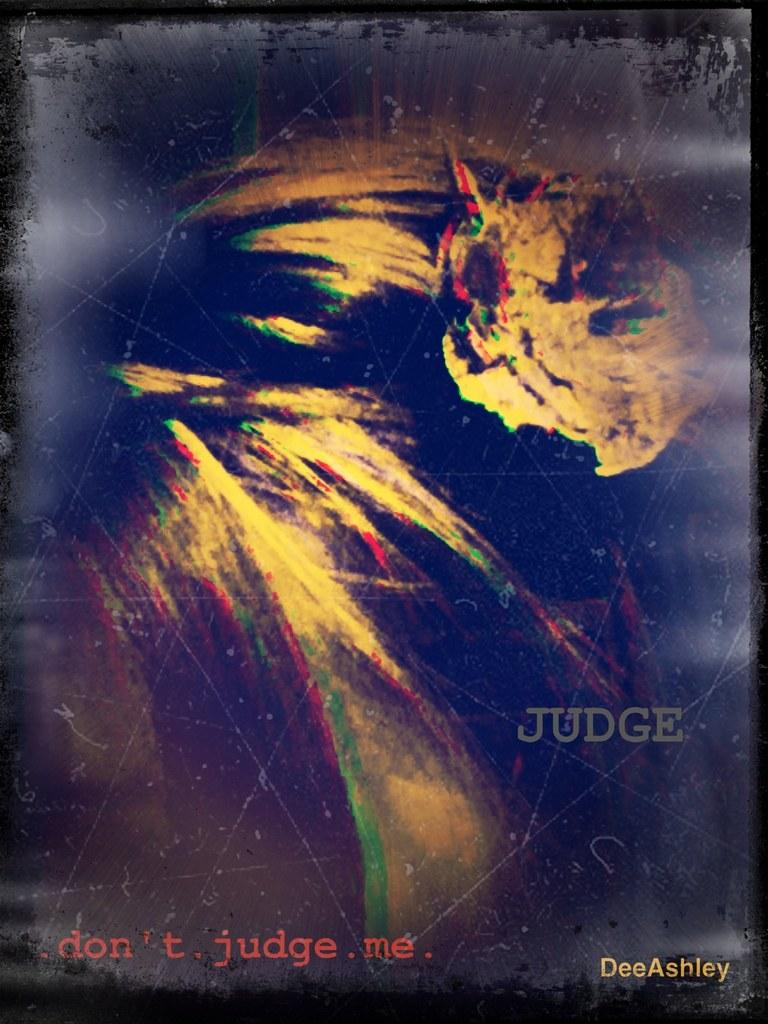<image>
Describe the image concisely. a photo of of earth that says dont judge me 